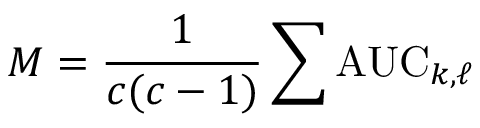<formula> <loc_0><loc_0><loc_500><loc_500>M = { \frac { 1 } { c ( c - 1 ) } } \sum A U C _ { k , \ell }</formula> 